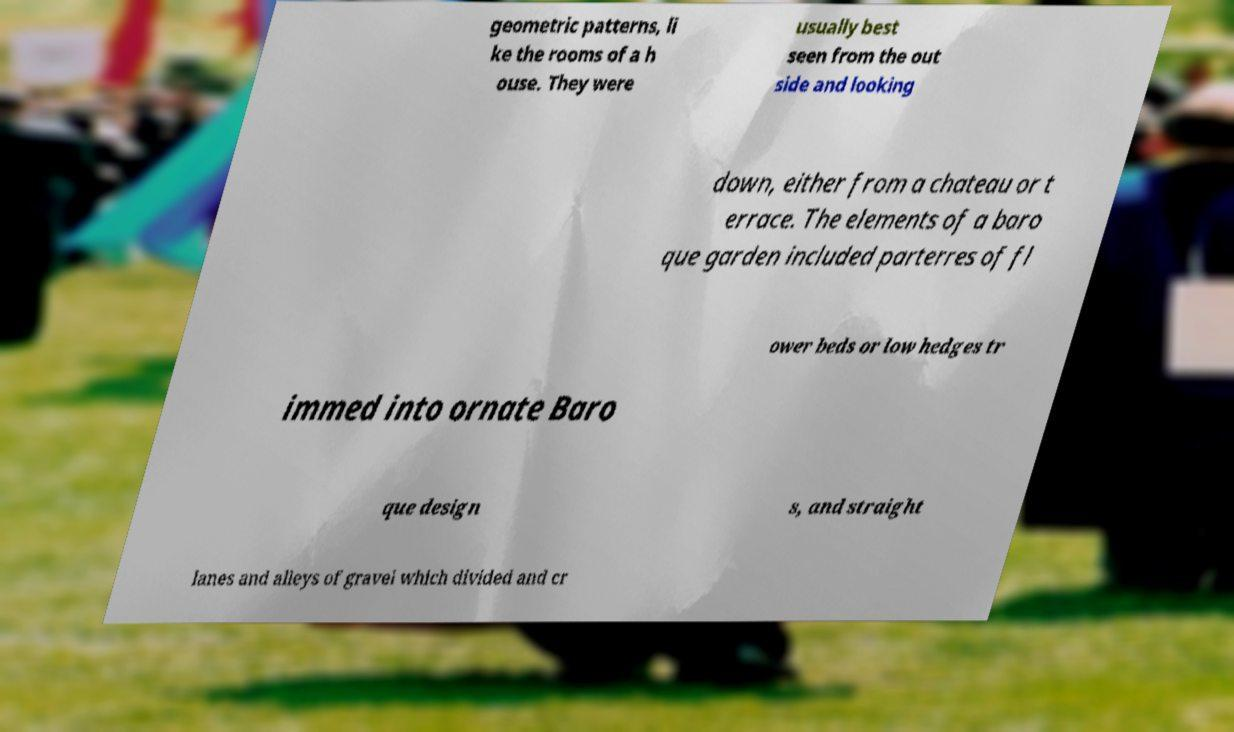There's text embedded in this image that I need extracted. Can you transcribe it verbatim? geometric patterns, li ke the rooms of a h ouse. They were usually best seen from the out side and looking down, either from a chateau or t errace. The elements of a baro que garden included parterres of fl ower beds or low hedges tr immed into ornate Baro que design s, and straight lanes and alleys of gravel which divided and cr 